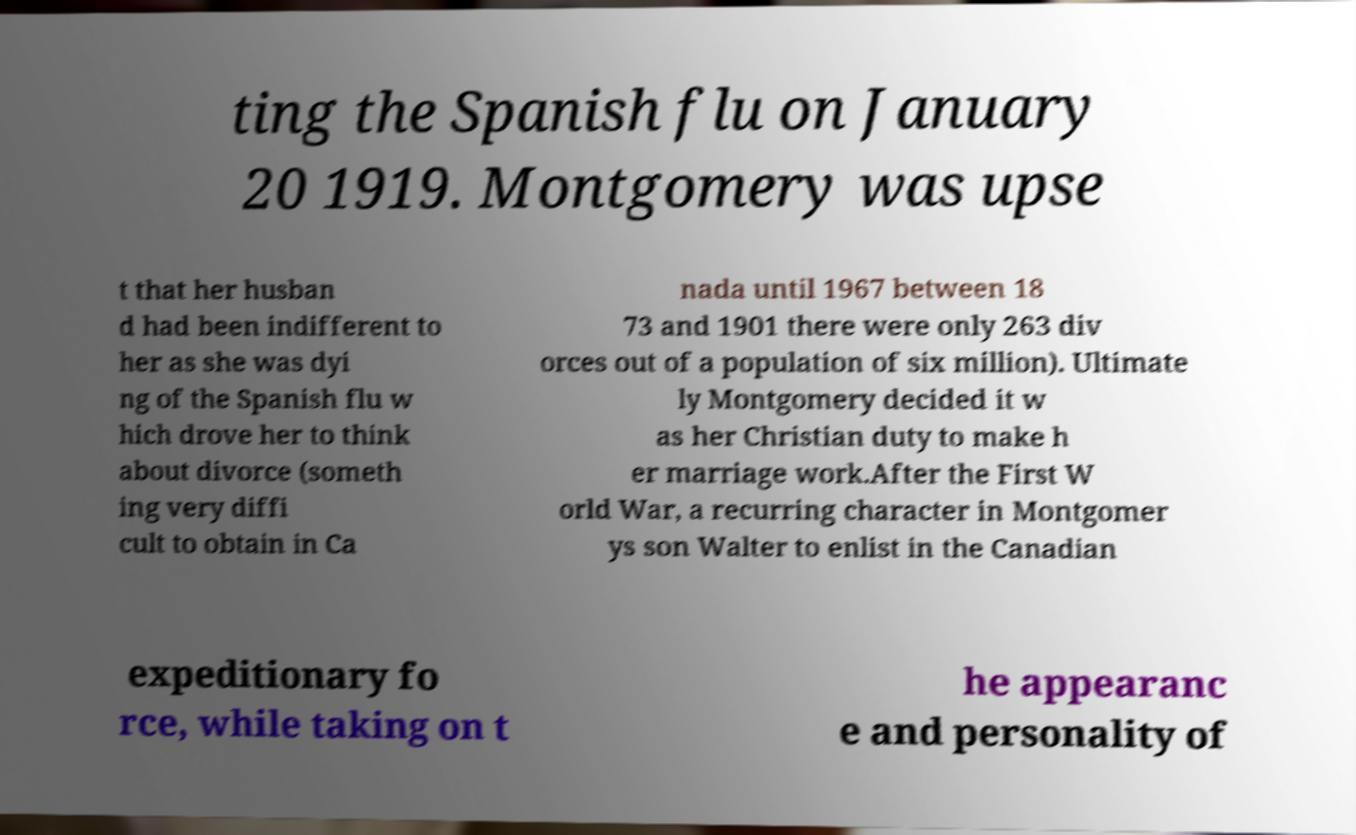Can you read and provide the text displayed in the image?This photo seems to have some interesting text. Can you extract and type it out for me? ting the Spanish flu on January 20 1919. Montgomery was upse t that her husban d had been indifferent to her as she was dyi ng of the Spanish flu w hich drove her to think about divorce (someth ing very diffi cult to obtain in Ca nada until 1967 between 18 73 and 1901 there were only 263 div orces out of a population of six million). Ultimate ly Montgomery decided it w as her Christian duty to make h er marriage work.After the First W orld War, a recurring character in Montgomer ys son Walter to enlist in the Canadian expeditionary fo rce, while taking on t he appearanc e and personality of 